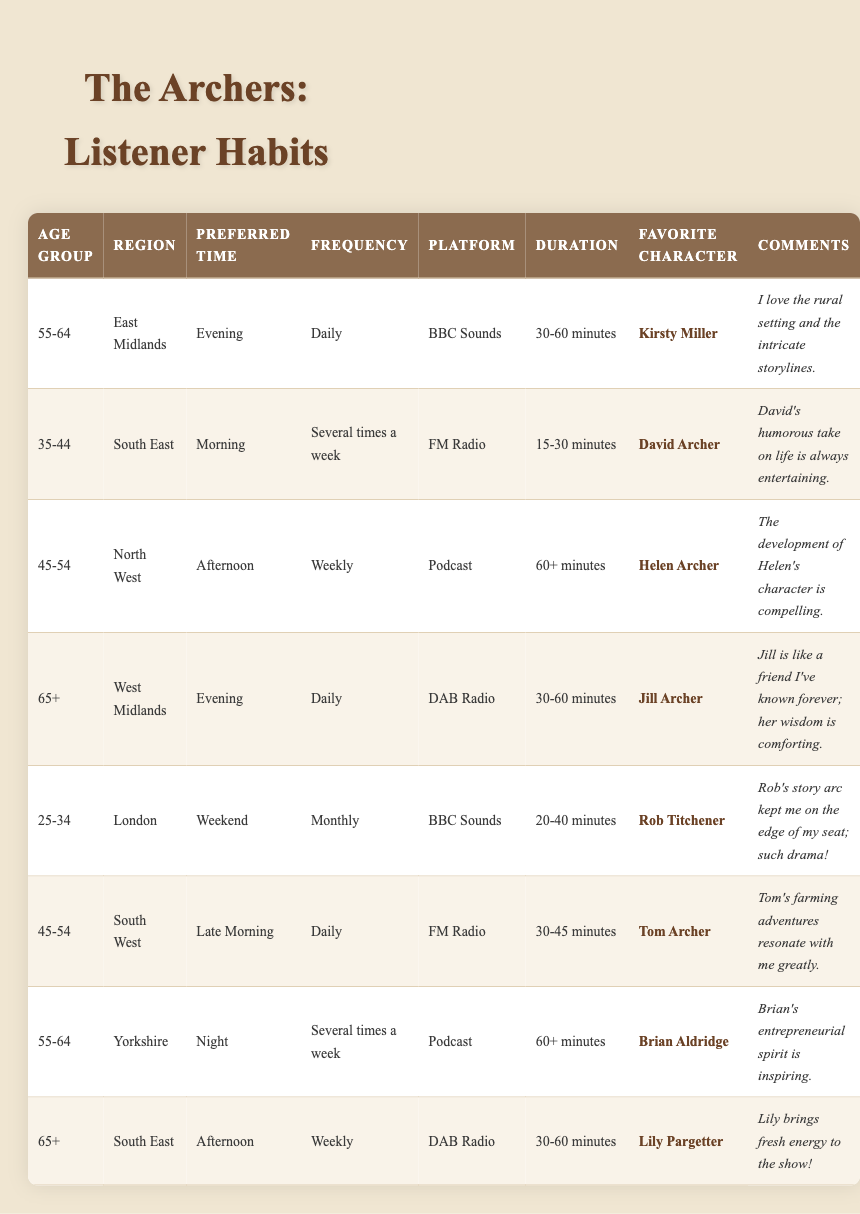What is the most popular listening platform among the respondents? By examining the table, we can see that the platforms used by listeners include BBC Sounds, FM Radio, Podcast, and DAB Radio. Each listener's platform is mentioned in the respective row. Counting the occurrences, we find that BBC Sounds is used by 3 listeners, FM Radio by 3, Podcast by 2, and DAB Radio by 2. Since BBC Sounds and FM Radio have the highest count, both can be considered equally popular.
Answer: BBC Sounds and FM Radio Which age group listens to "The Archers" the most frequently? In the table, we check the ListeningFrequency column to see how often each age group listens. The "Daily" frequency appears for the 55-64 and 65+ age groups, while "Several times a week" appears for the 55-64 age group. Thus, two age groups listen daily; we can say both 55-64 and 65+ are notable for frequent listening.
Answer: 55-64 and 65+ What are the preferred listening times for the youngest and oldest age groups? For the youngest age group (25-34), the preferred listening time is "Weekend," and for the oldest age group (65+), it is "Evening" and "Afternoon." Therefore, we have to list both preferred times from the data.
Answer: Weekend and Evening/Afternoon How many listeners prefer podcasts, and what is their average listening duration? To find how many listeners prefer podcasts, we filter the table for the Podcast platform, finding 3 listeners (ListenerID 3, 7). Their durations are 60+ minutes each. Since both have the same duration, the average remains 60+ minutes.
Answer: 3 listeners; average 60+ minutes Is David Archer the favorite character for more than two listeners? Checking the FavoriteCharacter column reveals "David Archer" appears only once associated with ListenerID 2. This means he is not the favorite character for more than two listeners.
Answer: No What is the combined listening frequency of listeners from the South East? We see that there are two listeners from the South East (ListenerID 2 and 8). Their frequencies are "Several times a week" and "Weekly." While these frequencies cannot be quantitatively added, collectively they indicate that listeners from this region connect at least 3-5 times weekly on average.
Answer: Weekly count 6-8 times Which character is most often described as comforting in listener comments? From scanning the ListenerComments section, Jill Archer is described as "like a friend I've known forever; her wisdom is comforting." Thus, Jill is the only character that is explicitly described in this way.
Answer: Jill Archer What is the most common duration selected by listeners? By analyzing the Duration column, we notice the most frequent categories are "30-60 minutes" and "60+ minutes." Counting them, we find "30-60 minutes" is mentioned 4 times and "60+ minutes" twice. Thus, "30-60 minutes" is the most common duration.
Answer: 30-60 minutes 